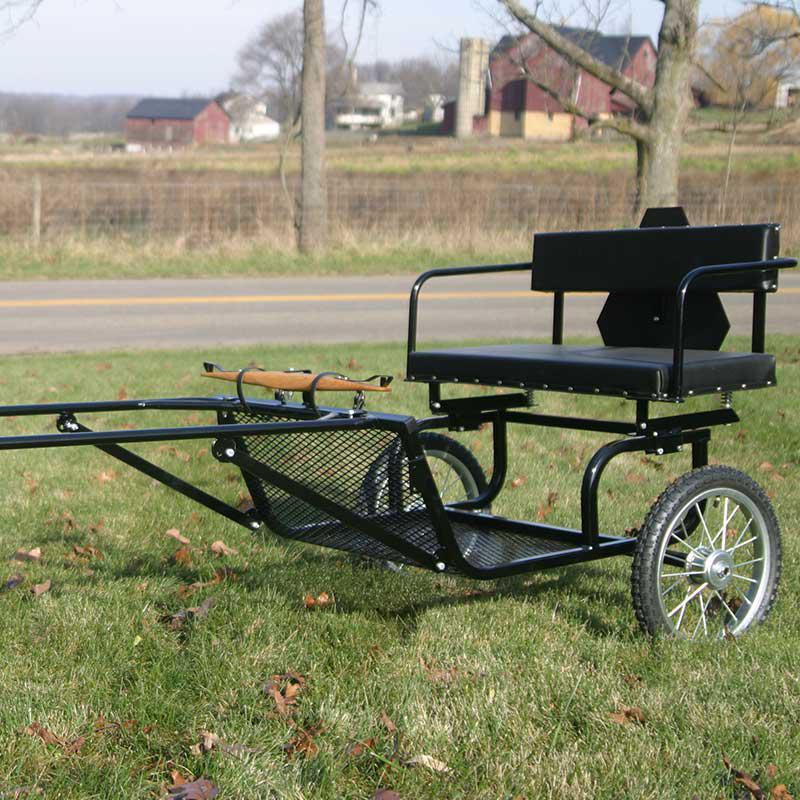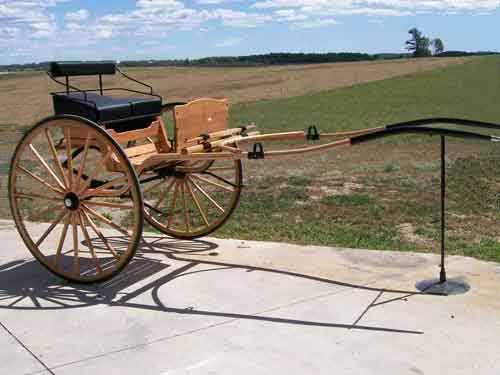The first image is the image on the left, the second image is the image on the right. Considering the images on both sides, is "At least one image features a black cart with metal grating for the foot rest." valid? Answer yes or no. Yes. The first image is the image on the left, the second image is the image on the right. Given the left and right images, does the statement "The foot rest of the buggy in the left photo is made from wooden slats." hold true? Answer yes or no. No. 